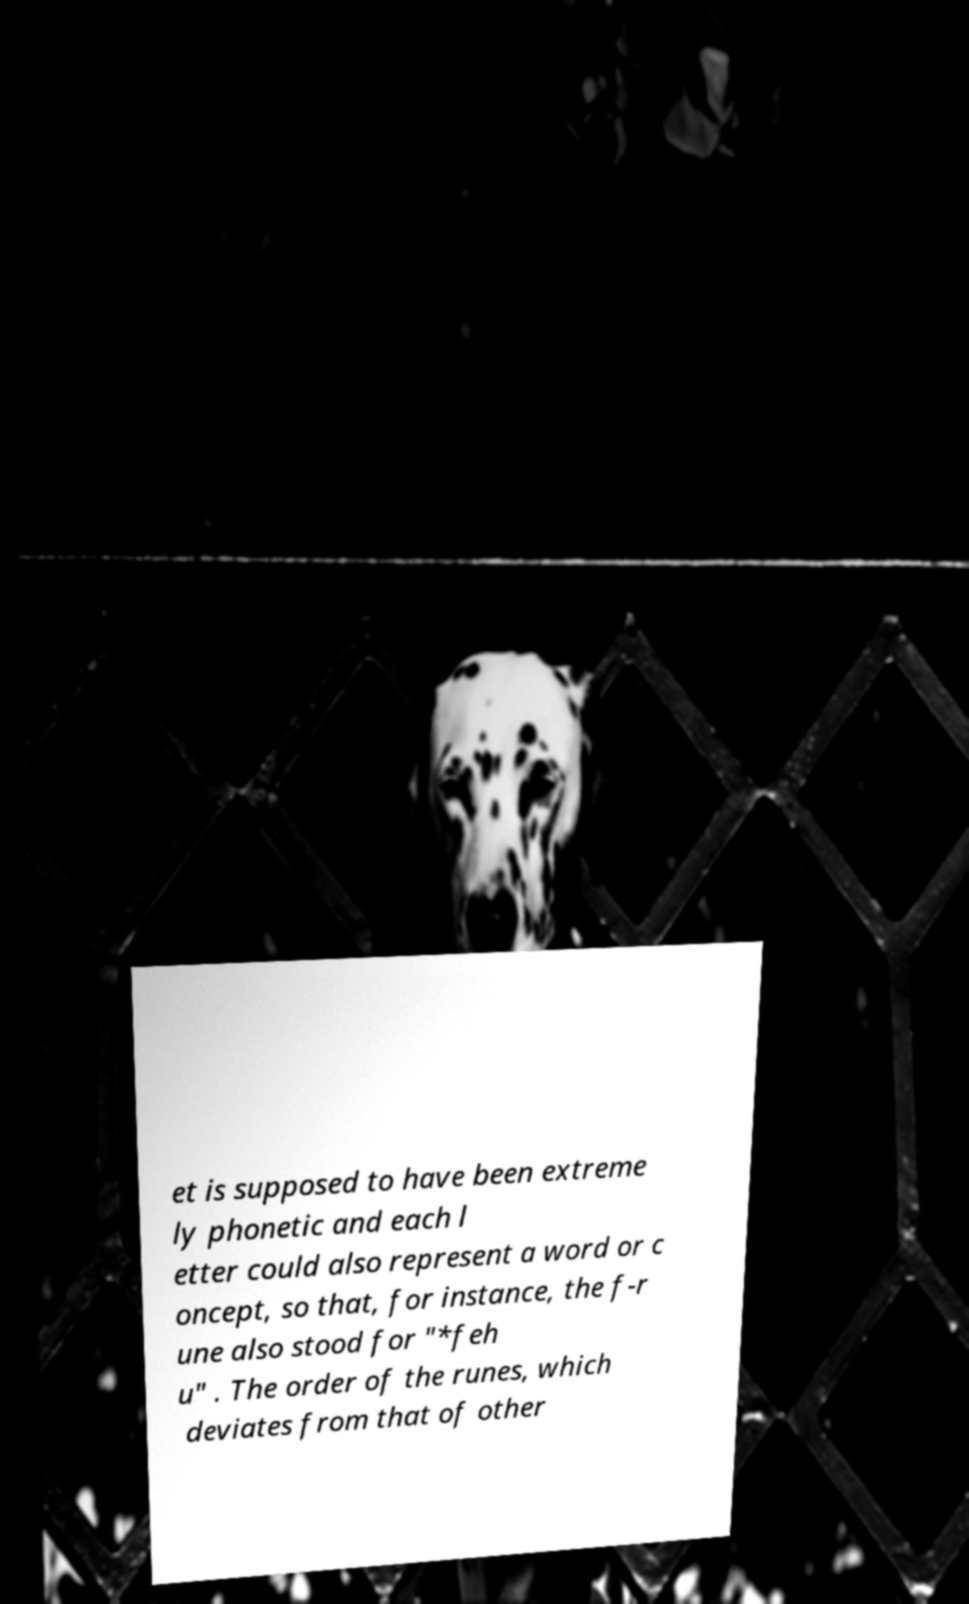Can you accurately transcribe the text from the provided image for me? et is supposed to have been extreme ly phonetic and each l etter could also represent a word or c oncept, so that, for instance, the f-r une also stood for "*feh u" . The order of the runes, which deviates from that of other 